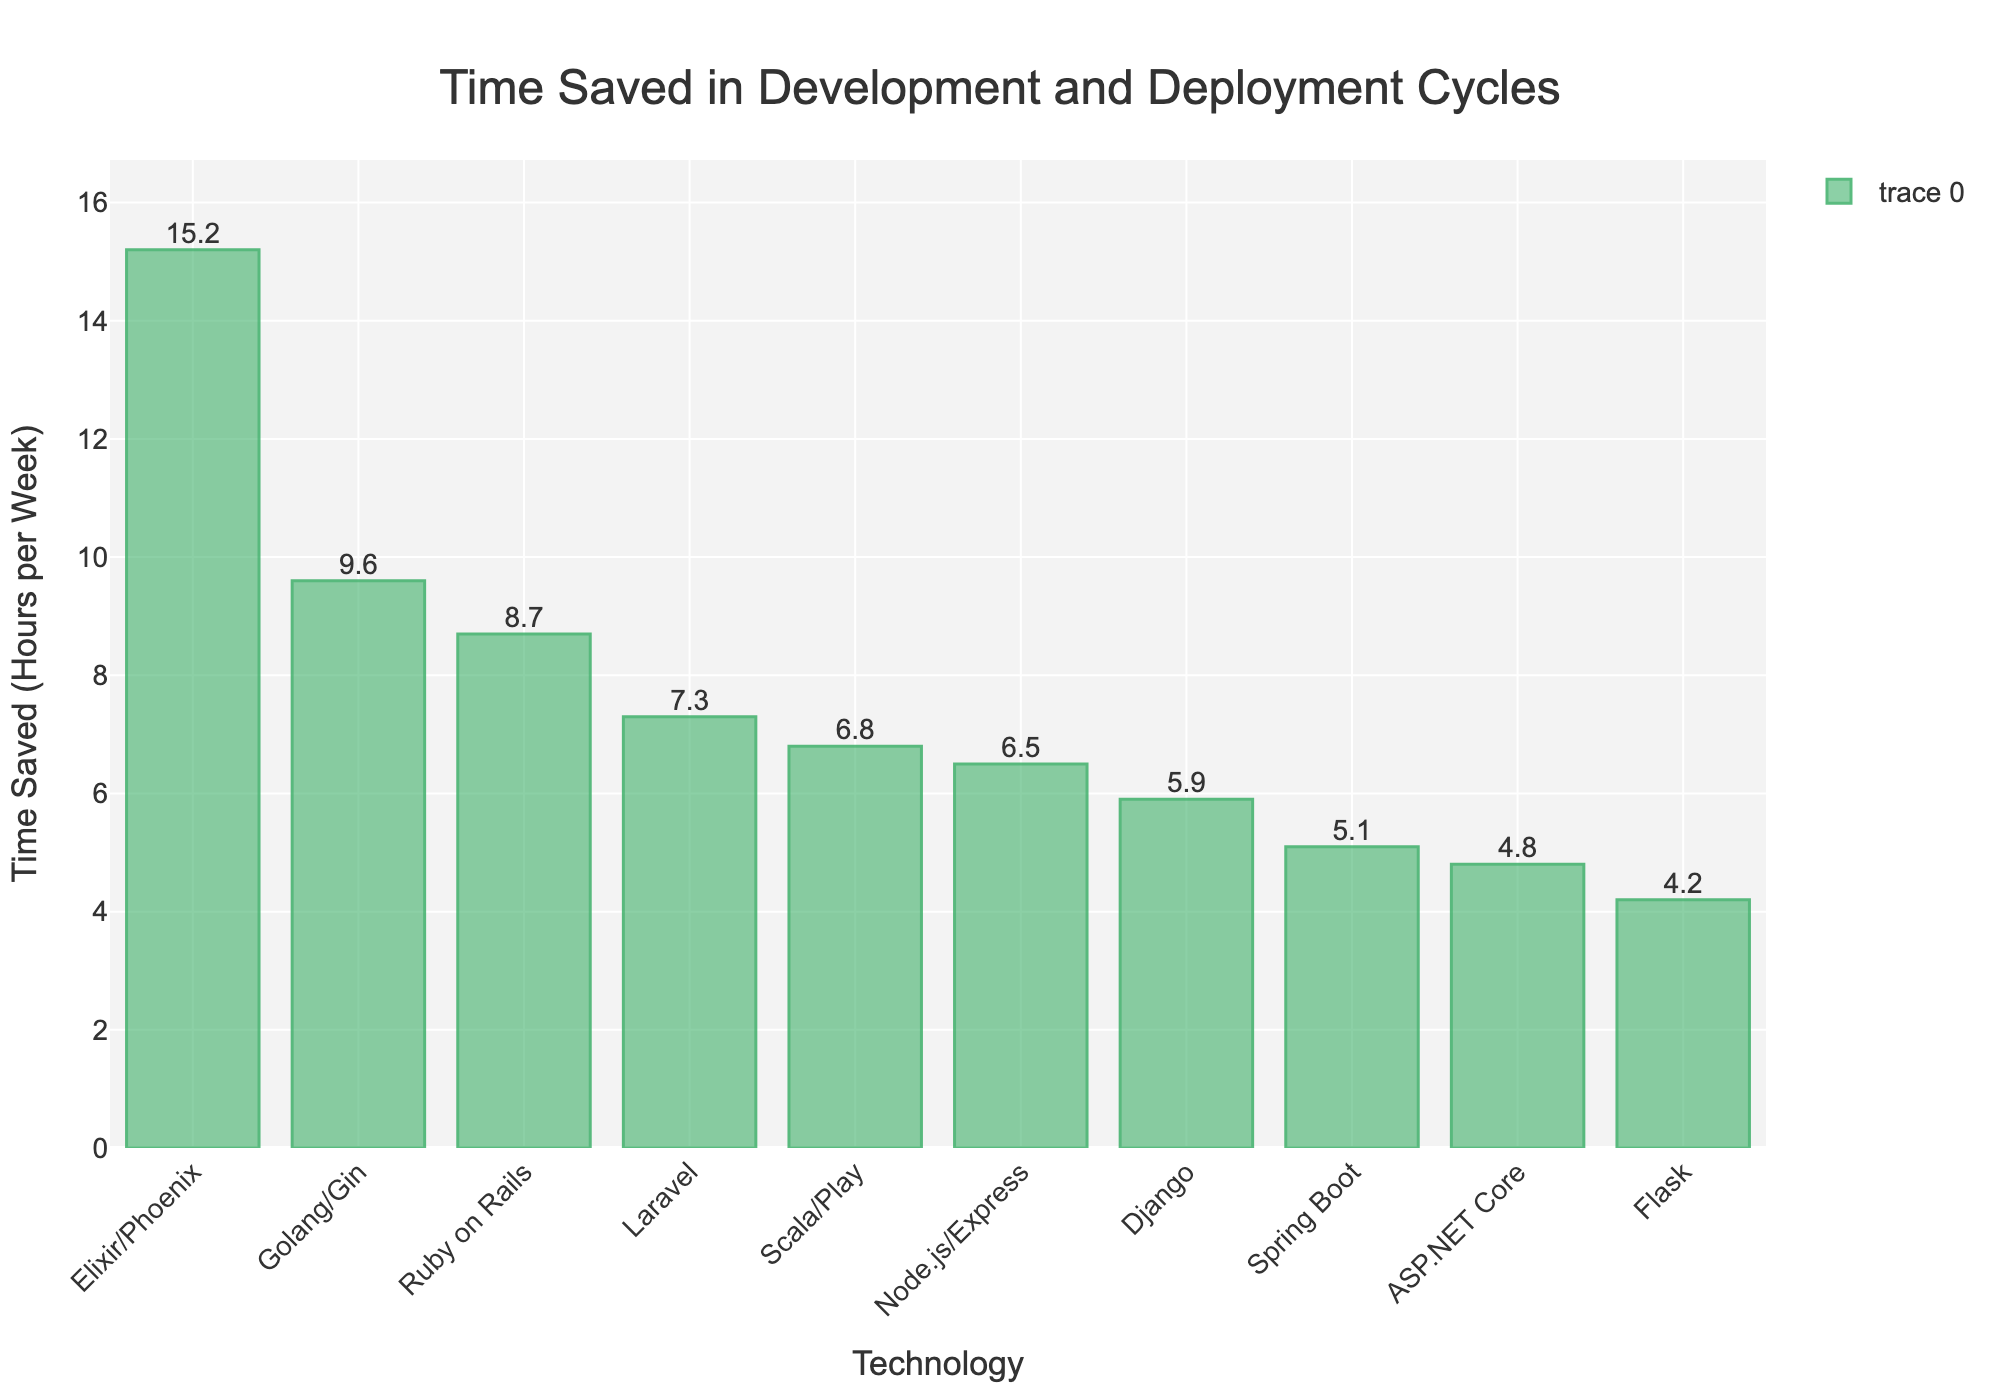Which technology saves the most time in development and deployment cycles? Look at the highest bar in the chart. The technology corresponding to the highest bar represents the one that saves the most time.
Answer: Elixir/Phoenix Which two technologies save the least amount of time? Identify the two shortest bars in the chart. The technologies corresponding to these bars are the ones that save the least amount of time.
Answer: Flask and ASP.NET Core How much more time does Elixir/Phoenix save compared to Ruby on Rails? Find the heights of the bars for Elixir/Phoenix and Ruby on Rails and subtract the latter from the former. Elixir/Phoenix saves 15.2 hours and Ruby on Rails saves 8.7 hours, so 15.2 - 8.7 = 6.5 hours.
Answer: 6.5 hours What is the average time saved across all technologies? Sum the time saved for all technologies and divide by the total number of technologies. The sum is 15.2 + 8.7 + 6.5 + 5.9 + 4.8 + 7.3 + 5.1 + 4.2 + 9.6 + 6.8 = 74.1. There are 10 technologies, so the average is 74.1 / 10 = 7.41 hours.
Answer: 7.41 hours Which technology saves more time: Django or Spring Boot? Compare the heights of the bars for Django and Spring Boot. The taller bar denotes the technology that saves more time. Django saves 5.9 hours, and Spring Boot saves 5.1 hours.
Answer: Django How much time does Laravel save in comparison to the average time saved across all technologies? Calculate the difference between Laravel's time-saving and the average time saved across all technologies. Laravel saves 7.3 hours, and the average is 7.41 hours, so 7.3 - 7.41 = -0.11 hours.
Answer: -0.11 hours Arrange the technologies that save more time than Node.js/Express in a descending order. Identify all technologies that have bars taller than Node.js/Express (which saves 6.5 hours). From the chart, these technologies are Elixir/Phoenix (15.2), Golang/Gin (9.6), Ruby on Rails (8.7), Scala/Play (6.8), and Laravel (7.3). Order them by height (time saved).
Answer: Elixir/Phoenix, Golang/Gin, Ruby on Rails, Laravel, Scala/Play Which technology saves just slightly more time than Flask? Look for the bar immediately taller than Flask (which saves 4.2 hours). The next tallest bar is ASP.NET Core, which saves 4.8 hours.
Answer: ASP.NET Core 